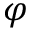Convert formula to latex. <formula><loc_0><loc_0><loc_500><loc_500>\varphi</formula> 